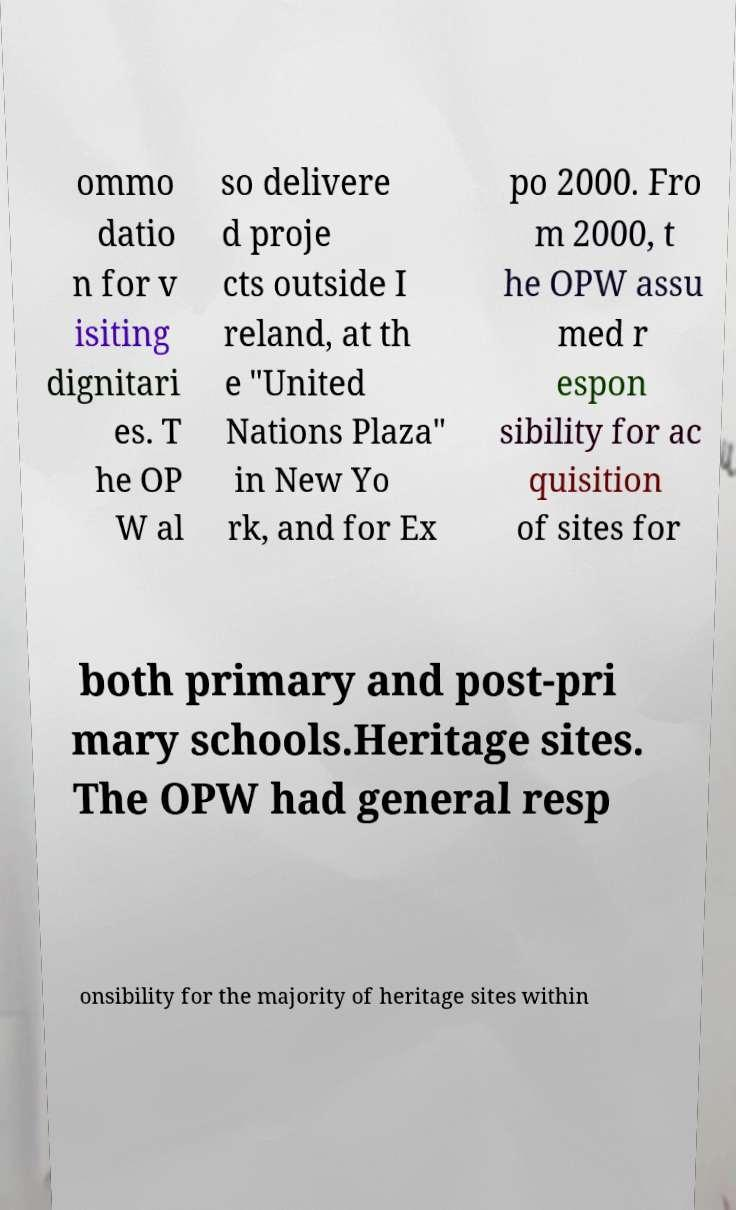Can you read and provide the text displayed in the image?This photo seems to have some interesting text. Can you extract and type it out for me? ommo datio n for v isiting dignitari es. T he OP W al so delivere d proje cts outside I reland, at th e "United Nations Plaza" in New Yo rk, and for Ex po 2000. Fro m 2000, t he OPW assu med r espon sibility for ac quisition of sites for both primary and post-pri mary schools.Heritage sites. The OPW had general resp onsibility for the majority of heritage sites within 